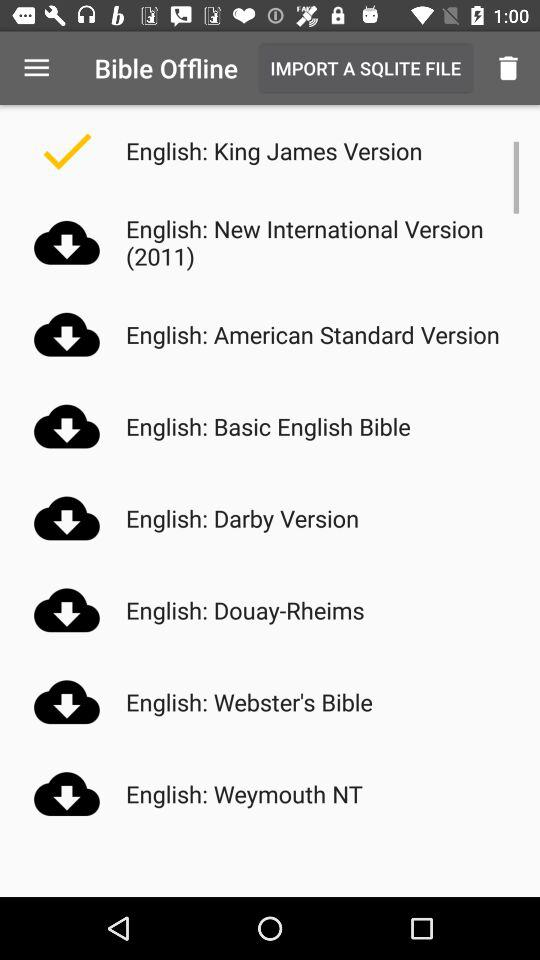How many English versions of the Bible have a check mark next to them?
Answer the question using a single word or phrase. 1 